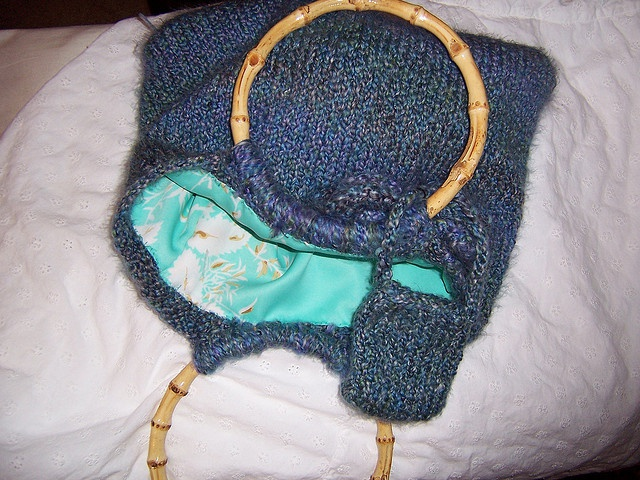Describe the objects in this image and their specific colors. I can see bed in black, lightgray, and darkgray tones and handbag in black, gray, navy, and blue tones in this image. 